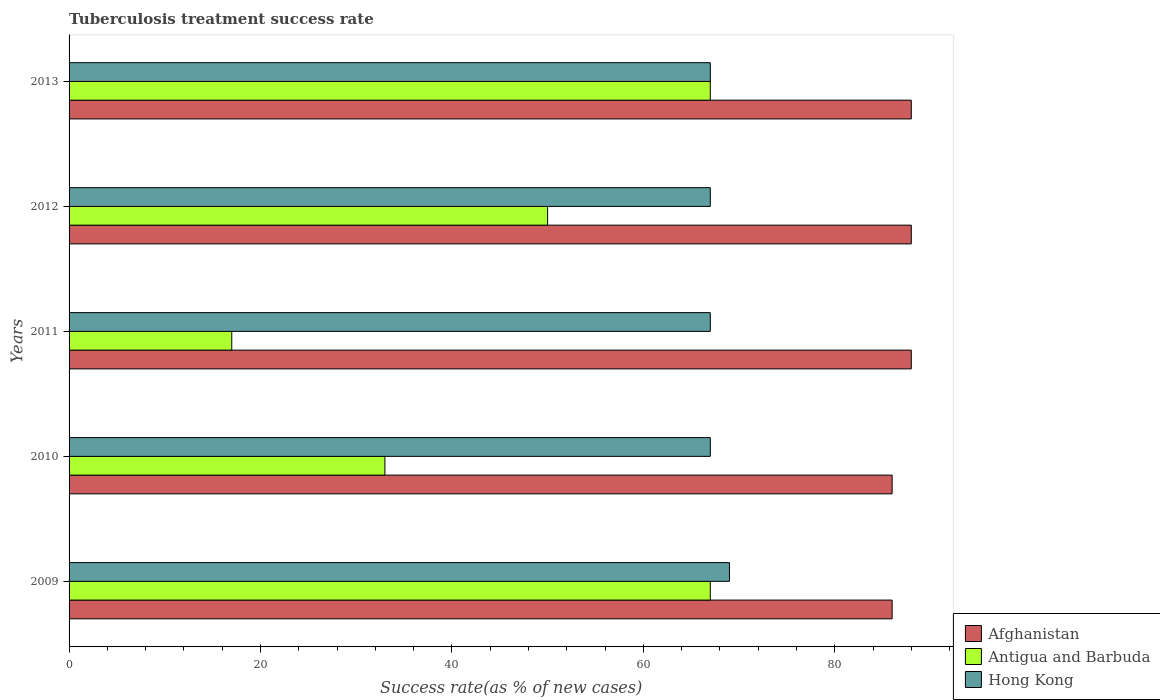How many groups of bars are there?
Keep it short and to the point. 5. Are the number of bars per tick equal to the number of legend labels?
Offer a very short reply. Yes. Are the number of bars on each tick of the Y-axis equal?
Your response must be concise. Yes. How many bars are there on the 3rd tick from the bottom?
Your answer should be compact. 3. What is the label of the 2nd group of bars from the top?
Give a very brief answer. 2012. In how many cases, is the number of bars for a given year not equal to the number of legend labels?
Your answer should be very brief. 0. What is the tuberculosis treatment success rate in Hong Kong in 2012?
Give a very brief answer. 67. Across all years, what is the minimum tuberculosis treatment success rate in Antigua and Barbuda?
Offer a very short reply. 17. What is the total tuberculosis treatment success rate in Antigua and Barbuda in the graph?
Make the answer very short. 234. What is the difference between the tuberculosis treatment success rate in Antigua and Barbuda in 2009 and that in 2011?
Keep it short and to the point. 50. What is the average tuberculosis treatment success rate in Antigua and Barbuda per year?
Offer a terse response. 46.8. In the year 2011, what is the difference between the tuberculosis treatment success rate in Afghanistan and tuberculosis treatment success rate in Hong Kong?
Give a very brief answer. 21. What is the ratio of the tuberculosis treatment success rate in Antigua and Barbuda in 2010 to that in 2011?
Ensure brevity in your answer.  1.94. Is the tuberculosis treatment success rate in Antigua and Barbuda in 2010 less than that in 2013?
Your response must be concise. Yes. Is the difference between the tuberculosis treatment success rate in Afghanistan in 2009 and 2011 greater than the difference between the tuberculosis treatment success rate in Hong Kong in 2009 and 2011?
Give a very brief answer. No. In how many years, is the tuberculosis treatment success rate in Hong Kong greater than the average tuberculosis treatment success rate in Hong Kong taken over all years?
Make the answer very short. 1. Is the sum of the tuberculosis treatment success rate in Hong Kong in 2009 and 2010 greater than the maximum tuberculosis treatment success rate in Afghanistan across all years?
Make the answer very short. Yes. What does the 1st bar from the top in 2012 represents?
Your answer should be compact. Hong Kong. What does the 3rd bar from the bottom in 2009 represents?
Make the answer very short. Hong Kong. How many years are there in the graph?
Make the answer very short. 5. Are the values on the major ticks of X-axis written in scientific E-notation?
Make the answer very short. No. Does the graph contain grids?
Provide a succinct answer. No. How many legend labels are there?
Your response must be concise. 3. What is the title of the graph?
Offer a very short reply. Tuberculosis treatment success rate. Does "Caribbean small states" appear as one of the legend labels in the graph?
Your answer should be compact. No. What is the label or title of the X-axis?
Your answer should be very brief. Success rate(as % of new cases). What is the Success rate(as % of new cases) in Antigua and Barbuda in 2010?
Provide a succinct answer. 33. What is the Success rate(as % of new cases) of Hong Kong in 2011?
Your answer should be very brief. 67. What is the Success rate(as % of new cases) of Afghanistan in 2012?
Provide a succinct answer. 88. What is the Success rate(as % of new cases) of Antigua and Barbuda in 2013?
Provide a succinct answer. 67. Across all years, what is the maximum Success rate(as % of new cases) in Antigua and Barbuda?
Provide a succinct answer. 67. Across all years, what is the maximum Success rate(as % of new cases) of Hong Kong?
Offer a very short reply. 69. What is the total Success rate(as % of new cases) in Afghanistan in the graph?
Provide a succinct answer. 436. What is the total Success rate(as % of new cases) of Antigua and Barbuda in the graph?
Offer a very short reply. 234. What is the total Success rate(as % of new cases) of Hong Kong in the graph?
Your answer should be compact. 337. What is the difference between the Success rate(as % of new cases) in Antigua and Barbuda in 2009 and that in 2010?
Your answer should be very brief. 34. What is the difference between the Success rate(as % of new cases) in Hong Kong in 2009 and that in 2010?
Your answer should be very brief. 2. What is the difference between the Success rate(as % of new cases) of Antigua and Barbuda in 2009 and that in 2011?
Provide a short and direct response. 50. What is the difference between the Success rate(as % of new cases) in Hong Kong in 2009 and that in 2011?
Make the answer very short. 2. What is the difference between the Success rate(as % of new cases) in Hong Kong in 2009 and that in 2012?
Your answer should be very brief. 2. What is the difference between the Success rate(as % of new cases) of Afghanistan in 2009 and that in 2013?
Give a very brief answer. -2. What is the difference between the Success rate(as % of new cases) in Antigua and Barbuda in 2009 and that in 2013?
Keep it short and to the point. 0. What is the difference between the Success rate(as % of new cases) of Hong Kong in 2009 and that in 2013?
Provide a short and direct response. 2. What is the difference between the Success rate(as % of new cases) in Afghanistan in 2010 and that in 2012?
Ensure brevity in your answer.  -2. What is the difference between the Success rate(as % of new cases) in Antigua and Barbuda in 2010 and that in 2012?
Ensure brevity in your answer.  -17. What is the difference between the Success rate(as % of new cases) in Afghanistan in 2010 and that in 2013?
Your response must be concise. -2. What is the difference between the Success rate(as % of new cases) in Antigua and Barbuda in 2010 and that in 2013?
Ensure brevity in your answer.  -34. What is the difference between the Success rate(as % of new cases) of Afghanistan in 2011 and that in 2012?
Keep it short and to the point. 0. What is the difference between the Success rate(as % of new cases) in Antigua and Barbuda in 2011 and that in 2012?
Keep it short and to the point. -33. What is the difference between the Success rate(as % of new cases) in Hong Kong in 2011 and that in 2013?
Provide a short and direct response. 0. What is the difference between the Success rate(as % of new cases) of Afghanistan in 2012 and that in 2013?
Provide a succinct answer. 0. What is the difference between the Success rate(as % of new cases) in Antigua and Barbuda in 2012 and that in 2013?
Offer a very short reply. -17. What is the difference between the Success rate(as % of new cases) in Afghanistan in 2009 and the Success rate(as % of new cases) in Hong Kong in 2010?
Provide a short and direct response. 19. What is the difference between the Success rate(as % of new cases) in Afghanistan in 2009 and the Success rate(as % of new cases) in Antigua and Barbuda in 2011?
Provide a succinct answer. 69. What is the difference between the Success rate(as % of new cases) of Afghanistan in 2009 and the Success rate(as % of new cases) of Hong Kong in 2011?
Give a very brief answer. 19. What is the difference between the Success rate(as % of new cases) of Antigua and Barbuda in 2009 and the Success rate(as % of new cases) of Hong Kong in 2011?
Provide a short and direct response. 0. What is the difference between the Success rate(as % of new cases) in Afghanistan in 2009 and the Success rate(as % of new cases) in Antigua and Barbuda in 2012?
Your answer should be very brief. 36. What is the difference between the Success rate(as % of new cases) of Antigua and Barbuda in 2009 and the Success rate(as % of new cases) of Hong Kong in 2012?
Your response must be concise. 0. What is the difference between the Success rate(as % of new cases) in Afghanistan in 2009 and the Success rate(as % of new cases) in Hong Kong in 2013?
Your answer should be very brief. 19. What is the difference between the Success rate(as % of new cases) in Antigua and Barbuda in 2009 and the Success rate(as % of new cases) in Hong Kong in 2013?
Your answer should be very brief. 0. What is the difference between the Success rate(as % of new cases) of Antigua and Barbuda in 2010 and the Success rate(as % of new cases) of Hong Kong in 2011?
Keep it short and to the point. -34. What is the difference between the Success rate(as % of new cases) in Antigua and Barbuda in 2010 and the Success rate(as % of new cases) in Hong Kong in 2012?
Your answer should be very brief. -34. What is the difference between the Success rate(as % of new cases) of Afghanistan in 2010 and the Success rate(as % of new cases) of Hong Kong in 2013?
Give a very brief answer. 19. What is the difference between the Success rate(as % of new cases) of Antigua and Barbuda in 2010 and the Success rate(as % of new cases) of Hong Kong in 2013?
Your answer should be compact. -34. What is the difference between the Success rate(as % of new cases) in Afghanistan in 2011 and the Success rate(as % of new cases) in Antigua and Barbuda in 2012?
Keep it short and to the point. 38. What is the difference between the Success rate(as % of new cases) in Antigua and Barbuda in 2011 and the Success rate(as % of new cases) in Hong Kong in 2012?
Offer a very short reply. -50. What is the difference between the Success rate(as % of new cases) in Afghanistan in 2011 and the Success rate(as % of new cases) in Antigua and Barbuda in 2013?
Your response must be concise. 21. What is the difference between the Success rate(as % of new cases) in Antigua and Barbuda in 2011 and the Success rate(as % of new cases) in Hong Kong in 2013?
Make the answer very short. -50. What is the difference between the Success rate(as % of new cases) of Antigua and Barbuda in 2012 and the Success rate(as % of new cases) of Hong Kong in 2013?
Your answer should be very brief. -17. What is the average Success rate(as % of new cases) in Afghanistan per year?
Your answer should be very brief. 87.2. What is the average Success rate(as % of new cases) in Antigua and Barbuda per year?
Offer a very short reply. 46.8. What is the average Success rate(as % of new cases) in Hong Kong per year?
Give a very brief answer. 67.4. In the year 2009, what is the difference between the Success rate(as % of new cases) in Afghanistan and Success rate(as % of new cases) in Antigua and Barbuda?
Ensure brevity in your answer.  19. In the year 2009, what is the difference between the Success rate(as % of new cases) of Afghanistan and Success rate(as % of new cases) of Hong Kong?
Make the answer very short. 17. In the year 2009, what is the difference between the Success rate(as % of new cases) of Antigua and Barbuda and Success rate(as % of new cases) of Hong Kong?
Your response must be concise. -2. In the year 2010, what is the difference between the Success rate(as % of new cases) in Afghanistan and Success rate(as % of new cases) in Hong Kong?
Offer a very short reply. 19. In the year 2010, what is the difference between the Success rate(as % of new cases) in Antigua and Barbuda and Success rate(as % of new cases) in Hong Kong?
Offer a very short reply. -34. In the year 2011, what is the difference between the Success rate(as % of new cases) in Afghanistan and Success rate(as % of new cases) in Hong Kong?
Offer a terse response. 21. In the year 2012, what is the difference between the Success rate(as % of new cases) in Afghanistan and Success rate(as % of new cases) in Antigua and Barbuda?
Your answer should be compact. 38. In the year 2013, what is the difference between the Success rate(as % of new cases) of Antigua and Barbuda and Success rate(as % of new cases) of Hong Kong?
Your response must be concise. 0. What is the ratio of the Success rate(as % of new cases) in Antigua and Barbuda in 2009 to that in 2010?
Provide a succinct answer. 2.03. What is the ratio of the Success rate(as % of new cases) of Hong Kong in 2009 to that in 2010?
Ensure brevity in your answer.  1.03. What is the ratio of the Success rate(as % of new cases) of Afghanistan in 2009 to that in 2011?
Provide a succinct answer. 0.98. What is the ratio of the Success rate(as % of new cases) of Antigua and Barbuda in 2009 to that in 2011?
Offer a terse response. 3.94. What is the ratio of the Success rate(as % of new cases) of Hong Kong in 2009 to that in 2011?
Your answer should be compact. 1.03. What is the ratio of the Success rate(as % of new cases) of Afghanistan in 2009 to that in 2012?
Your answer should be compact. 0.98. What is the ratio of the Success rate(as % of new cases) in Antigua and Barbuda in 2009 to that in 2012?
Keep it short and to the point. 1.34. What is the ratio of the Success rate(as % of new cases) in Hong Kong in 2009 to that in 2012?
Keep it short and to the point. 1.03. What is the ratio of the Success rate(as % of new cases) in Afghanistan in 2009 to that in 2013?
Your answer should be very brief. 0.98. What is the ratio of the Success rate(as % of new cases) of Hong Kong in 2009 to that in 2013?
Keep it short and to the point. 1.03. What is the ratio of the Success rate(as % of new cases) in Afghanistan in 2010 to that in 2011?
Keep it short and to the point. 0.98. What is the ratio of the Success rate(as % of new cases) of Antigua and Barbuda in 2010 to that in 2011?
Give a very brief answer. 1.94. What is the ratio of the Success rate(as % of new cases) of Hong Kong in 2010 to that in 2011?
Ensure brevity in your answer.  1. What is the ratio of the Success rate(as % of new cases) in Afghanistan in 2010 to that in 2012?
Keep it short and to the point. 0.98. What is the ratio of the Success rate(as % of new cases) of Antigua and Barbuda in 2010 to that in 2012?
Your answer should be compact. 0.66. What is the ratio of the Success rate(as % of new cases) in Hong Kong in 2010 to that in 2012?
Ensure brevity in your answer.  1. What is the ratio of the Success rate(as % of new cases) in Afghanistan in 2010 to that in 2013?
Your answer should be compact. 0.98. What is the ratio of the Success rate(as % of new cases) of Antigua and Barbuda in 2010 to that in 2013?
Your answer should be compact. 0.49. What is the ratio of the Success rate(as % of new cases) of Afghanistan in 2011 to that in 2012?
Your response must be concise. 1. What is the ratio of the Success rate(as % of new cases) in Antigua and Barbuda in 2011 to that in 2012?
Ensure brevity in your answer.  0.34. What is the ratio of the Success rate(as % of new cases) of Antigua and Barbuda in 2011 to that in 2013?
Ensure brevity in your answer.  0.25. What is the ratio of the Success rate(as % of new cases) of Antigua and Barbuda in 2012 to that in 2013?
Give a very brief answer. 0.75. What is the ratio of the Success rate(as % of new cases) of Hong Kong in 2012 to that in 2013?
Provide a short and direct response. 1. What is the difference between the highest and the second highest Success rate(as % of new cases) of Afghanistan?
Give a very brief answer. 0. What is the difference between the highest and the second highest Success rate(as % of new cases) in Hong Kong?
Offer a very short reply. 2. What is the difference between the highest and the lowest Success rate(as % of new cases) of Afghanistan?
Your answer should be very brief. 2. What is the difference between the highest and the lowest Success rate(as % of new cases) of Antigua and Barbuda?
Ensure brevity in your answer.  50. What is the difference between the highest and the lowest Success rate(as % of new cases) of Hong Kong?
Offer a very short reply. 2. 